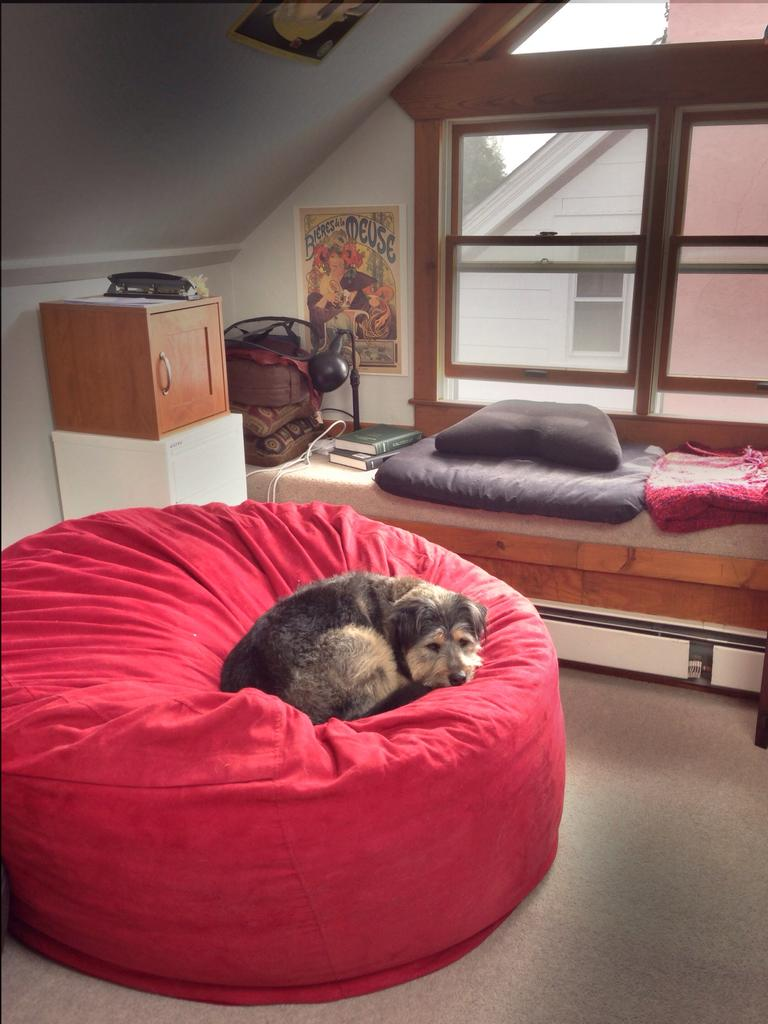What is the dog doing in the image? The dog is sitting on a bean bag in the image. What type of furniture can be seen in the image besides the bean bag? There are cupboards and a bed in the image. What is on the bed in the image? The bed has a pillow, blanket, books, and a lamp on it. Is there any source of natural light in the image? Yes, there is a window in the image. How many kittens are playing on the oven in the image? There is no oven or kittens present in the image. 